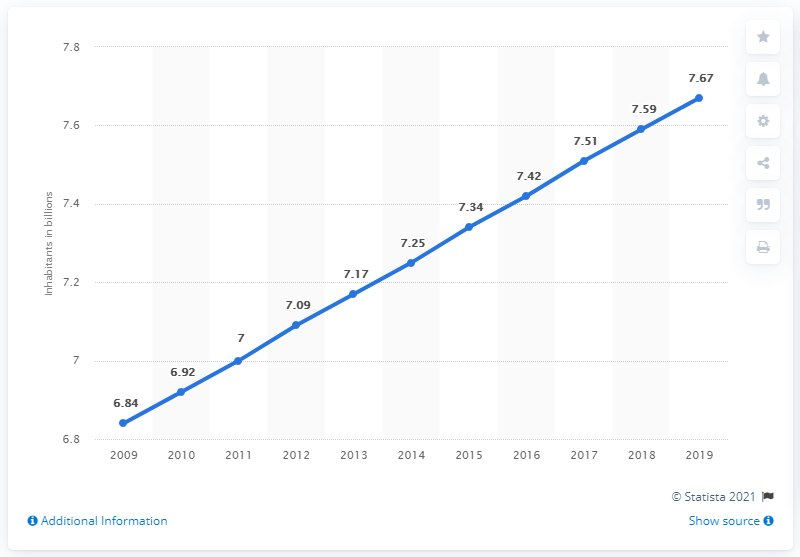Draw attention to some important aspects in this diagram. The population of the region has been increasing over the years. The total population of 2010 and 2011 was 13.92 billion, according to the given data. In 2019, the world's population was approximately 7.67 billion. 